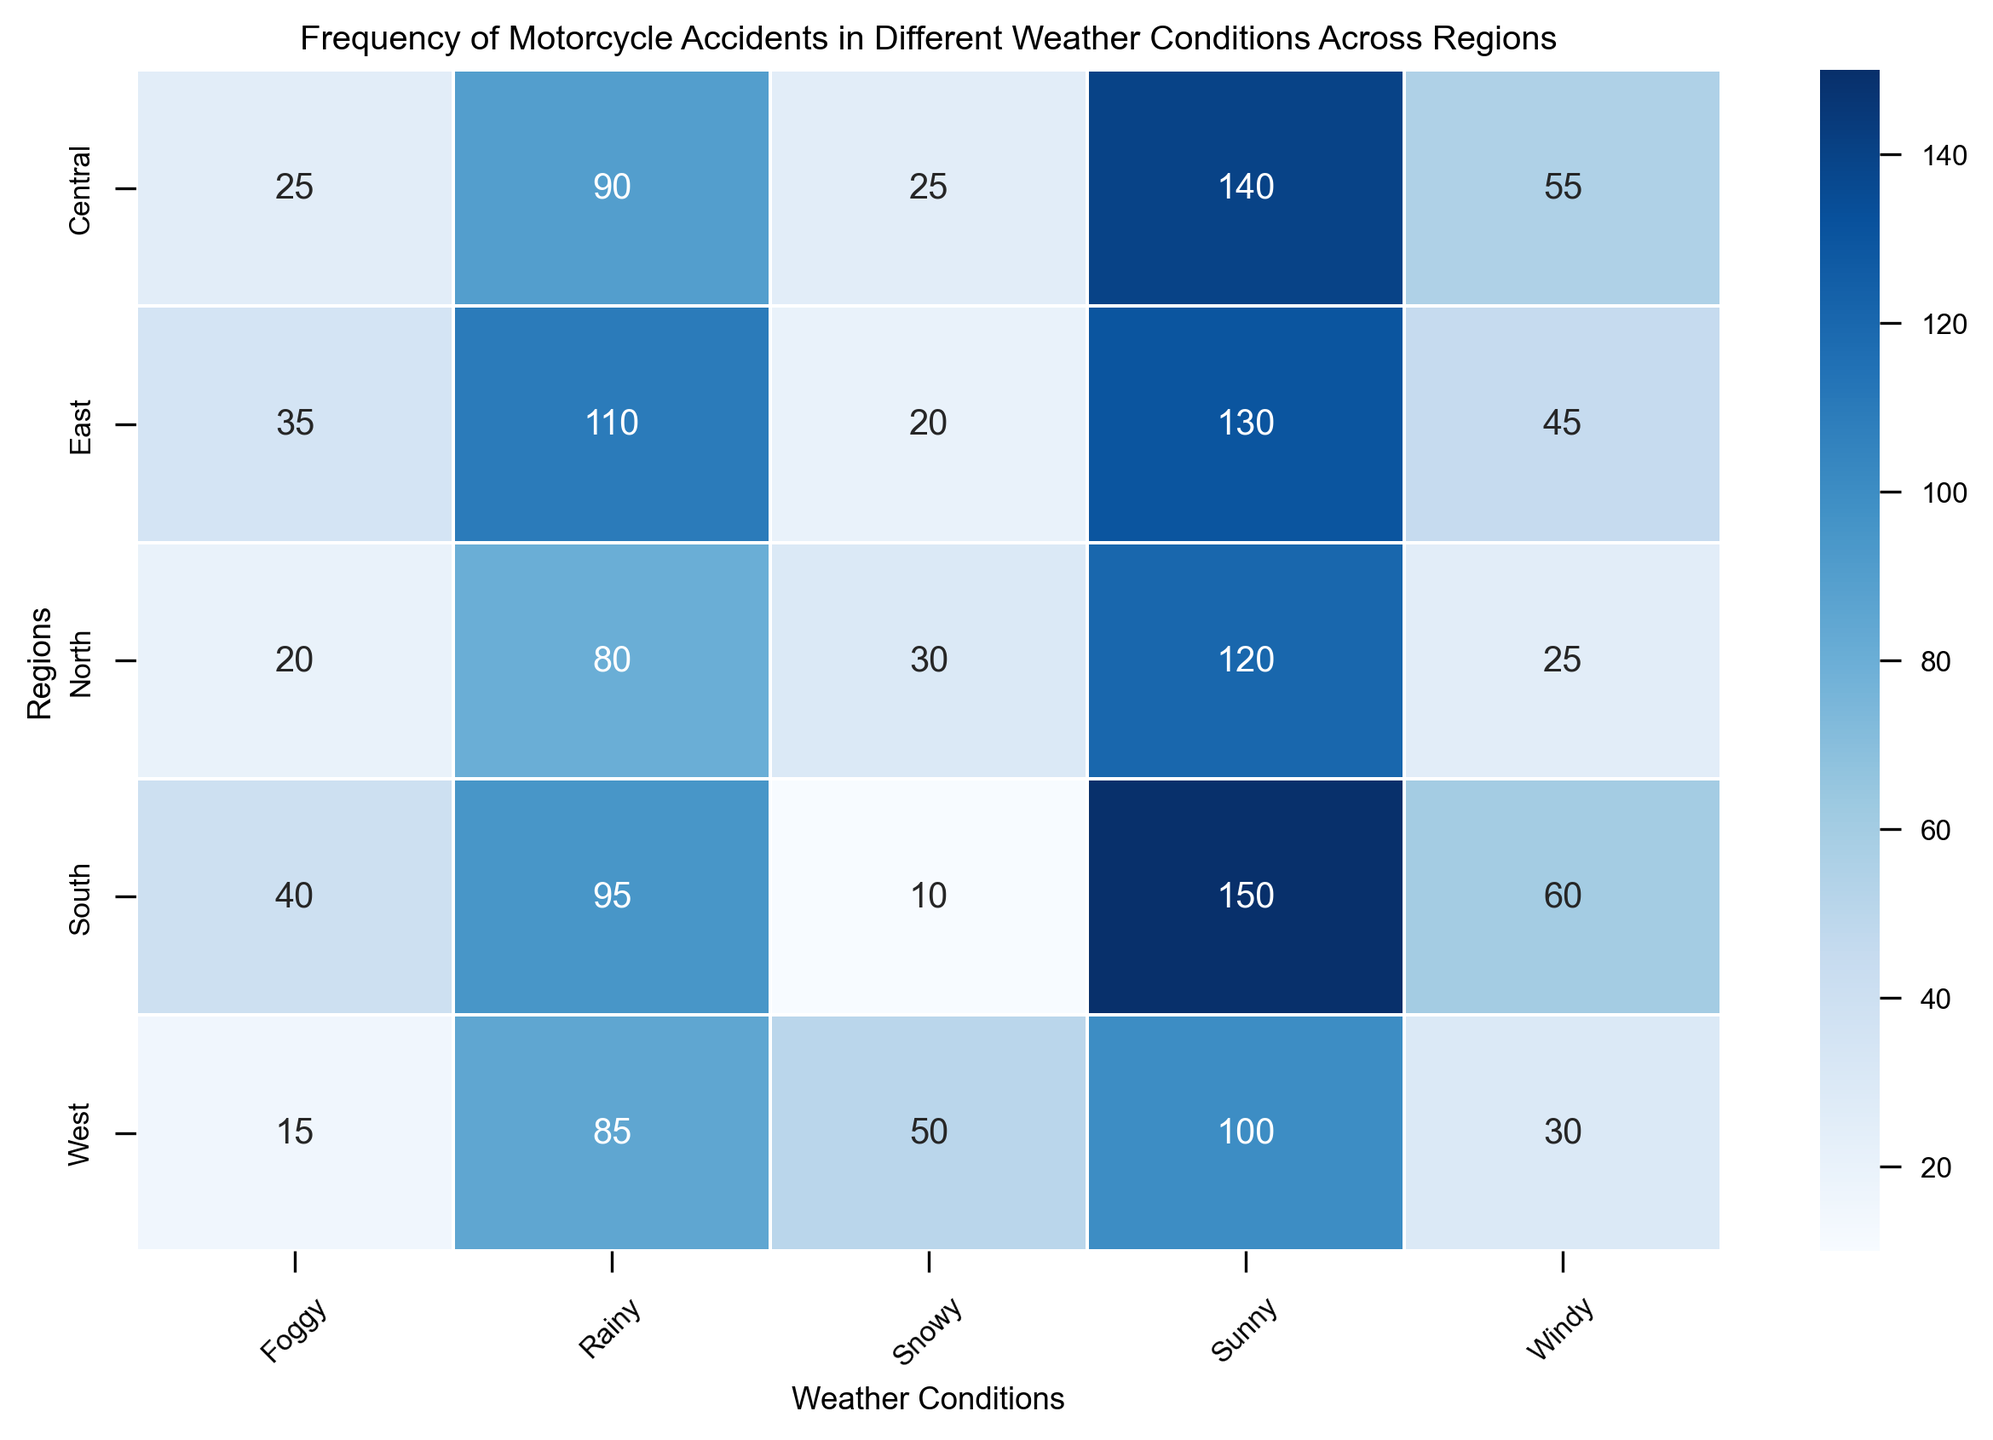Which region has the highest frequency of motorcycle accidents in sunny weather? Look at the heatmap and identify the cell corresponding to 'Sunny' weather and the various regions. Compare the values in these cells.
Answer: South Which weather condition has the lowest frequency of accidents in the East region? Check the row corresponding to the East region and observe the frequency values for all weather conditions. Identify the lowest value.
Answer: Snowy Which region experiences more motorcycle accidents in foggy weather, North or Central? Compare the values in the 'Foggy' column for the North and Central rows.
Answer: South What is the total number of accidents in the West region across all weather conditions? Add the frequency values for each weather condition in the West row: 100 (Sunny) + 85 (Rainy) + 50 (Snowy) + 15 (Foggy) + 30 (Windy).
Answer: 280 Which region has more accidents in snowy weather: North or West? Find the values in the 'Snowy' column for North and West rows, and compare them.
Answer: West Rank the regions from highest to lowest frequency of motorcycle accidents in windy weather. Observe the 'Windy' column and evaluate the values for each region. Rank them in descending order.
Answer: Central (55), South (60), East (45), West (30), North (25) What is the average frequency of motorcycle accidents in rainy weather across all regions? Sum the frequency values in the 'Rainy' column (80 + 95 + 110 + 85 + 90) and divide by the number of regions, which is 5.
Answer: 92 Are motorcycle accidents more frequent in foggy or windy conditions in the North region? Compare the frequency values for 'Foggy' and 'Windy' conditions in the North row.
Answer: Windy What is the difference in the frequency of motorcycle accidents between sunny and rainy weather in the Central region? Subtract the frequency value of rainy weather from sunny weather in the Central row: 140 (Sunny) - 90 (Rainy).
Answer: 50 Which region shows the highest frequency of motorcycle accidents in foggy weather and how many accidents were recorded? Observe the 'Foggy' column and find the highest value among all regions, then note the region and the corresponding frequency.
Answer: South, 40 